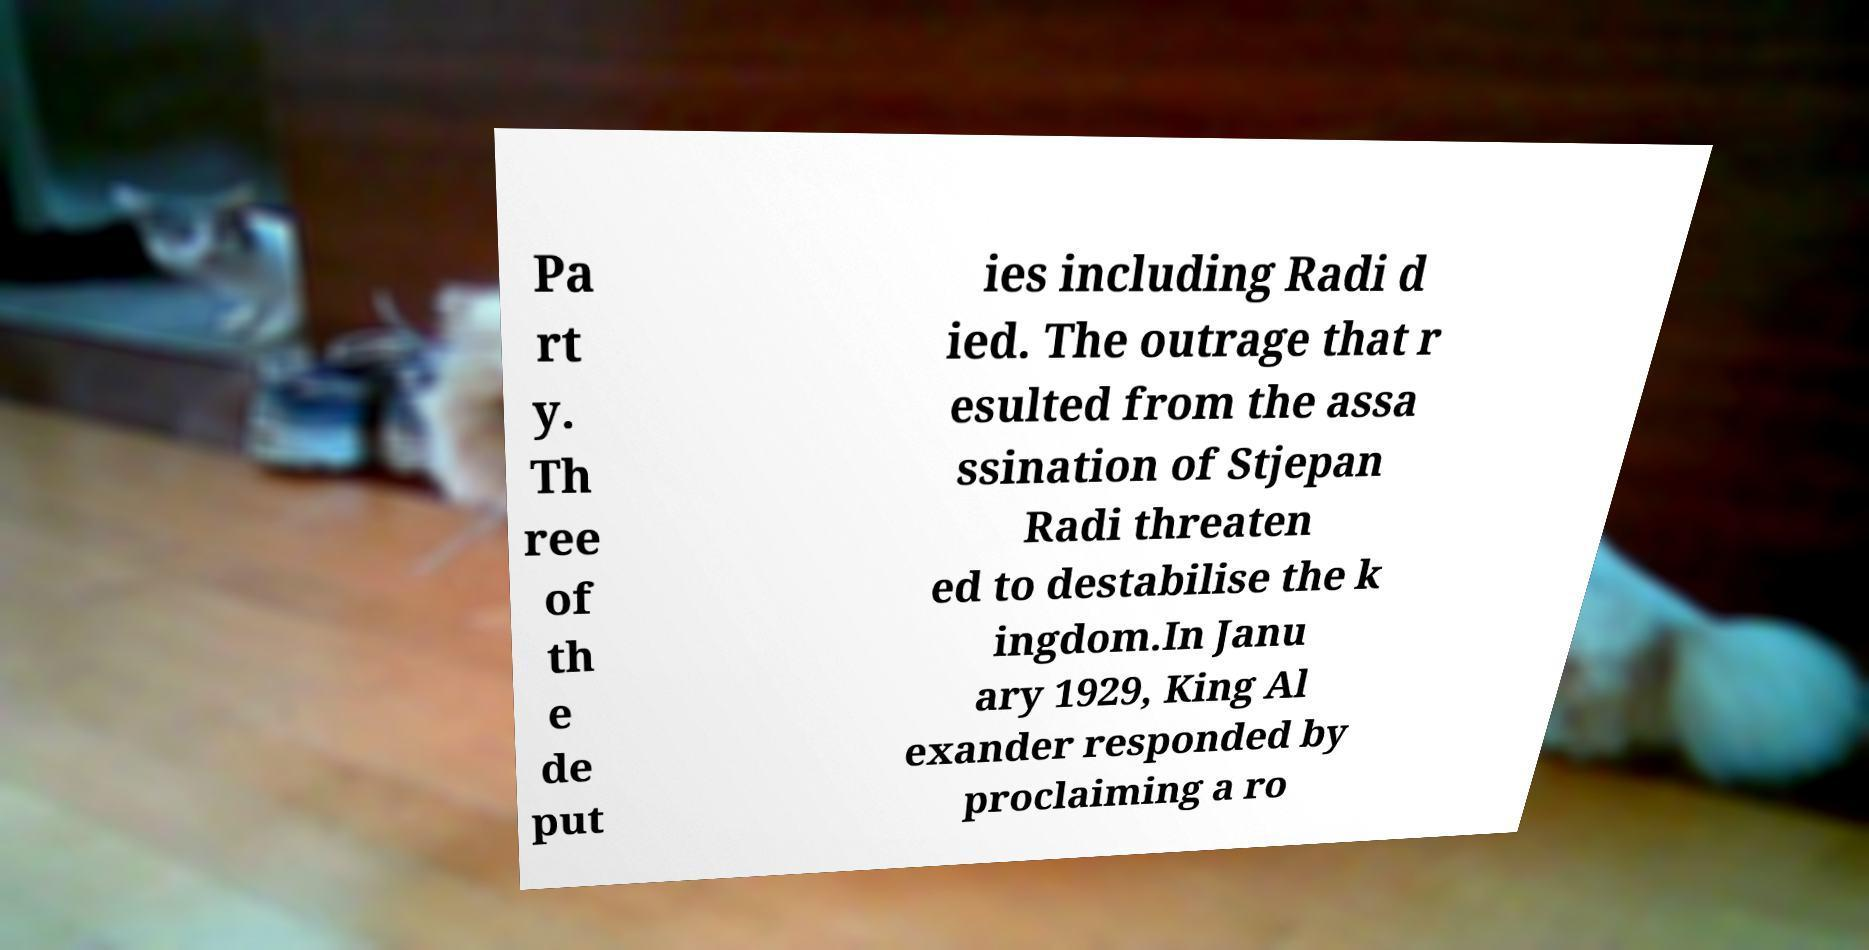Could you extract and type out the text from this image? Pa rt y. Th ree of th e de put ies including Radi d ied. The outrage that r esulted from the assa ssination of Stjepan Radi threaten ed to destabilise the k ingdom.In Janu ary 1929, King Al exander responded by proclaiming a ro 